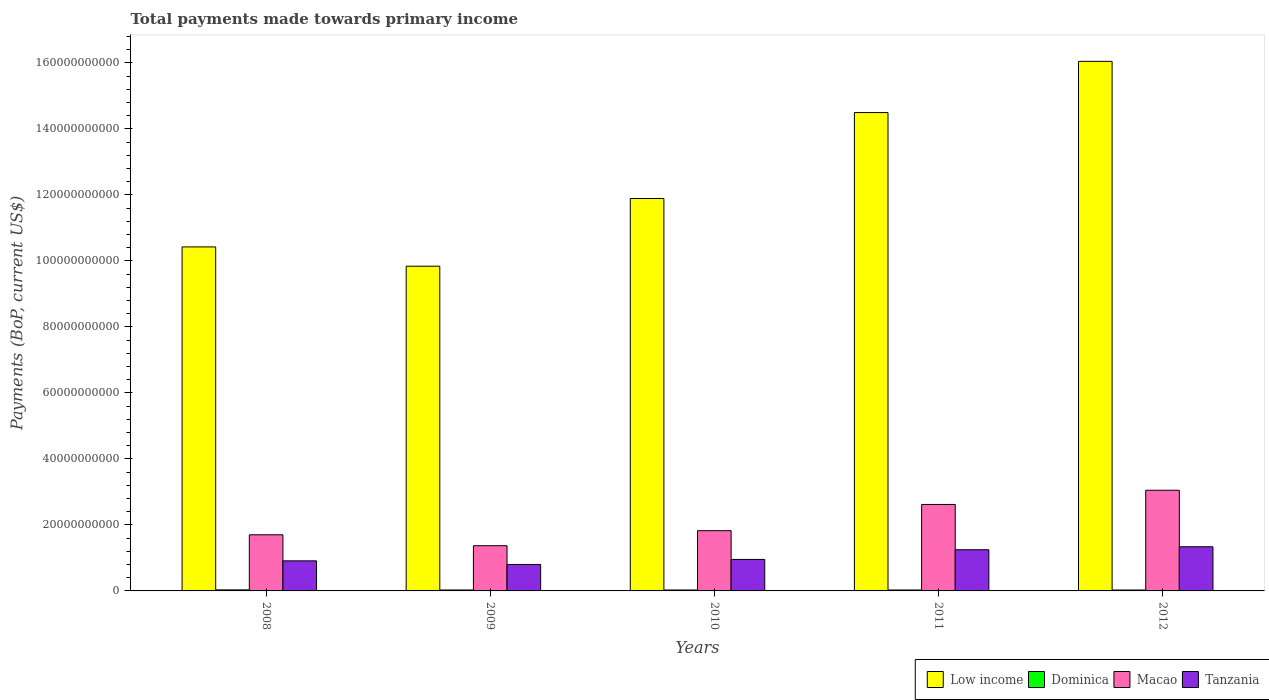How many different coloured bars are there?
Provide a short and direct response. 4. How many groups of bars are there?
Offer a terse response. 5. Are the number of bars on each tick of the X-axis equal?
Your answer should be very brief. Yes. How many bars are there on the 5th tick from the left?
Provide a succinct answer. 4. How many bars are there on the 4th tick from the right?
Your answer should be compact. 4. What is the label of the 2nd group of bars from the left?
Your answer should be very brief. 2009. What is the total payments made towards primary income in Tanzania in 2012?
Make the answer very short. 1.34e+1. Across all years, what is the maximum total payments made towards primary income in Dominica?
Give a very brief answer. 3.14e+08. Across all years, what is the minimum total payments made towards primary income in Macao?
Offer a very short reply. 1.37e+1. In which year was the total payments made towards primary income in Macao maximum?
Keep it short and to the point. 2012. What is the total total payments made towards primary income in Dominica in the graph?
Your response must be concise. 1.43e+09. What is the difference between the total payments made towards primary income in Macao in 2011 and that in 2012?
Give a very brief answer. -4.30e+09. What is the difference between the total payments made towards primary income in Low income in 2008 and the total payments made towards primary income in Macao in 2009?
Your response must be concise. 9.05e+1. What is the average total payments made towards primary income in Low income per year?
Your answer should be compact. 1.25e+11. In the year 2012, what is the difference between the total payments made towards primary income in Macao and total payments made towards primary income in Tanzania?
Make the answer very short. 1.71e+1. In how many years, is the total payments made towards primary income in Dominica greater than 160000000000 US$?
Offer a terse response. 0. What is the ratio of the total payments made towards primary income in Tanzania in 2010 to that in 2012?
Offer a very short reply. 0.71. Is the total payments made towards primary income in Macao in 2011 less than that in 2012?
Your response must be concise. Yes. What is the difference between the highest and the second highest total payments made towards primary income in Macao?
Offer a very short reply. 4.30e+09. What is the difference between the highest and the lowest total payments made towards primary income in Dominica?
Provide a short and direct response. 4.01e+07. What does the 3rd bar from the left in 2010 represents?
Your response must be concise. Macao. Is it the case that in every year, the sum of the total payments made towards primary income in Tanzania and total payments made towards primary income in Dominica is greater than the total payments made towards primary income in Macao?
Keep it short and to the point. No. Are all the bars in the graph horizontal?
Ensure brevity in your answer.  No. Are the values on the major ticks of Y-axis written in scientific E-notation?
Your response must be concise. No. Where does the legend appear in the graph?
Offer a terse response. Bottom right. How are the legend labels stacked?
Your answer should be compact. Horizontal. What is the title of the graph?
Your answer should be very brief. Total payments made towards primary income. What is the label or title of the X-axis?
Make the answer very short. Years. What is the label or title of the Y-axis?
Keep it short and to the point. Payments (BoP, current US$). What is the Payments (BoP, current US$) in Low income in 2008?
Offer a very short reply. 1.04e+11. What is the Payments (BoP, current US$) in Dominica in 2008?
Provide a succinct answer. 3.14e+08. What is the Payments (BoP, current US$) in Macao in 2008?
Provide a succinct answer. 1.70e+1. What is the Payments (BoP, current US$) of Tanzania in 2008?
Give a very brief answer. 9.11e+09. What is the Payments (BoP, current US$) of Low income in 2009?
Provide a succinct answer. 9.84e+1. What is the Payments (BoP, current US$) of Dominica in 2009?
Offer a very short reply. 2.85e+08. What is the Payments (BoP, current US$) of Macao in 2009?
Your answer should be compact. 1.37e+1. What is the Payments (BoP, current US$) in Tanzania in 2009?
Offer a very short reply. 8.02e+09. What is the Payments (BoP, current US$) of Low income in 2010?
Provide a succinct answer. 1.19e+11. What is the Payments (BoP, current US$) in Dominica in 2010?
Give a very brief answer. 2.80e+08. What is the Payments (BoP, current US$) in Macao in 2010?
Your answer should be compact. 1.83e+1. What is the Payments (BoP, current US$) in Tanzania in 2010?
Provide a succinct answer. 9.54e+09. What is the Payments (BoP, current US$) in Low income in 2011?
Your response must be concise. 1.45e+11. What is the Payments (BoP, current US$) in Dominica in 2011?
Give a very brief answer. 2.80e+08. What is the Payments (BoP, current US$) in Macao in 2011?
Your answer should be compact. 2.62e+1. What is the Payments (BoP, current US$) in Tanzania in 2011?
Your answer should be compact. 1.25e+1. What is the Payments (BoP, current US$) of Low income in 2012?
Provide a short and direct response. 1.60e+11. What is the Payments (BoP, current US$) in Dominica in 2012?
Provide a succinct answer. 2.74e+08. What is the Payments (BoP, current US$) in Macao in 2012?
Make the answer very short. 3.05e+1. What is the Payments (BoP, current US$) of Tanzania in 2012?
Offer a very short reply. 1.34e+1. Across all years, what is the maximum Payments (BoP, current US$) of Low income?
Offer a terse response. 1.60e+11. Across all years, what is the maximum Payments (BoP, current US$) of Dominica?
Your answer should be very brief. 3.14e+08. Across all years, what is the maximum Payments (BoP, current US$) in Macao?
Give a very brief answer. 3.05e+1. Across all years, what is the maximum Payments (BoP, current US$) of Tanzania?
Your response must be concise. 1.34e+1. Across all years, what is the minimum Payments (BoP, current US$) of Low income?
Give a very brief answer. 9.84e+1. Across all years, what is the minimum Payments (BoP, current US$) of Dominica?
Your answer should be very brief. 2.74e+08. Across all years, what is the minimum Payments (BoP, current US$) in Macao?
Give a very brief answer. 1.37e+1. Across all years, what is the minimum Payments (BoP, current US$) of Tanzania?
Keep it short and to the point. 8.02e+09. What is the total Payments (BoP, current US$) of Low income in the graph?
Provide a succinct answer. 6.27e+11. What is the total Payments (BoP, current US$) of Dominica in the graph?
Your answer should be compact. 1.43e+09. What is the total Payments (BoP, current US$) in Macao in the graph?
Offer a very short reply. 1.06e+11. What is the total Payments (BoP, current US$) in Tanzania in the graph?
Give a very brief answer. 5.25e+1. What is the difference between the Payments (BoP, current US$) of Low income in 2008 and that in 2009?
Your answer should be compact. 5.85e+09. What is the difference between the Payments (BoP, current US$) of Dominica in 2008 and that in 2009?
Your answer should be compact. 2.94e+07. What is the difference between the Payments (BoP, current US$) of Macao in 2008 and that in 2009?
Your response must be concise. 3.31e+09. What is the difference between the Payments (BoP, current US$) in Tanzania in 2008 and that in 2009?
Offer a very short reply. 1.10e+09. What is the difference between the Payments (BoP, current US$) of Low income in 2008 and that in 2010?
Ensure brevity in your answer.  -1.47e+1. What is the difference between the Payments (BoP, current US$) in Dominica in 2008 and that in 2010?
Give a very brief answer. 3.40e+07. What is the difference between the Payments (BoP, current US$) in Macao in 2008 and that in 2010?
Keep it short and to the point. -1.25e+09. What is the difference between the Payments (BoP, current US$) of Tanzania in 2008 and that in 2010?
Your answer should be very brief. -4.30e+08. What is the difference between the Payments (BoP, current US$) of Low income in 2008 and that in 2011?
Provide a short and direct response. -4.07e+1. What is the difference between the Payments (BoP, current US$) of Dominica in 2008 and that in 2011?
Provide a short and direct response. 3.38e+07. What is the difference between the Payments (BoP, current US$) of Macao in 2008 and that in 2011?
Make the answer very short. -9.19e+09. What is the difference between the Payments (BoP, current US$) of Tanzania in 2008 and that in 2011?
Your answer should be compact. -3.37e+09. What is the difference between the Payments (BoP, current US$) of Low income in 2008 and that in 2012?
Offer a terse response. -5.62e+1. What is the difference between the Payments (BoP, current US$) in Dominica in 2008 and that in 2012?
Offer a very short reply. 4.01e+07. What is the difference between the Payments (BoP, current US$) in Macao in 2008 and that in 2012?
Keep it short and to the point. -1.35e+1. What is the difference between the Payments (BoP, current US$) of Tanzania in 2008 and that in 2012?
Make the answer very short. -4.27e+09. What is the difference between the Payments (BoP, current US$) in Low income in 2009 and that in 2010?
Keep it short and to the point. -2.05e+1. What is the difference between the Payments (BoP, current US$) of Dominica in 2009 and that in 2010?
Offer a very short reply. 4.64e+06. What is the difference between the Payments (BoP, current US$) in Macao in 2009 and that in 2010?
Your answer should be compact. -4.56e+09. What is the difference between the Payments (BoP, current US$) of Tanzania in 2009 and that in 2010?
Offer a terse response. -1.53e+09. What is the difference between the Payments (BoP, current US$) of Low income in 2009 and that in 2011?
Your response must be concise. -4.66e+1. What is the difference between the Payments (BoP, current US$) of Dominica in 2009 and that in 2011?
Provide a succinct answer. 4.40e+06. What is the difference between the Payments (BoP, current US$) of Macao in 2009 and that in 2011?
Offer a terse response. -1.25e+1. What is the difference between the Payments (BoP, current US$) of Tanzania in 2009 and that in 2011?
Ensure brevity in your answer.  -4.46e+09. What is the difference between the Payments (BoP, current US$) in Low income in 2009 and that in 2012?
Offer a very short reply. -6.21e+1. What is the difference between the Payments (BoP, current US$) in Dominica in 2009 and that in 2012?
Your answer should be compact. 1.07e+07. What is the difference between the Payments (BoP, current US$) of Macao in 2009 and that in 2012?
Provide a succinct answer. -1.68e+1. What is the difference between the Payments (BoP, current US$) of Tanzania in 2009 and that in 2012?
Your answer should be very brief. -5.37e+09. What is the difference between the Payments (BoP, current US$) in Low income in 2010 and that in 2011?
Provide a short and direct response. -2.60e+1. What is the difference between the Payments (BoP, current US$) of Dominica in 2010 and that in 2011?
Keep it short and to the point. -2.36e+05. What is the difference between the Payments (BoP, current US$) in Macao in 2010 and that in 2011?
Give a very brief answer. -7.95e+09. What is the difference between the Payments (BoP, current US$) in Tanzania in 2010 and that in 2011?
Keep it short and to the point. -2.94e+09. What is the difference between the Payments (BoP, current US$) in Low income in 2010 and that in 2012?
Your response must be concise. -4.16e+1. What is the difference between the Payments (BoP, current US$) of Dominica in 2010 and that in 2012?
Make the answer very short. 6.09e+06. What is the difference between the Payments (BoP, current US$) in Macao in 2010 and that in 2012?
Make the answer very short. -1.22e+1. What is the difference between the Payments (BoP, current US$) in Tanzania in 2010 and that in 2012?
Provide a short and direct response. -3.84e+09. What is the difference between the Payments (BoP, current US$) in Low income in 2011 and that in 2012?
Your answer should be compact. -1.55e+1. What is the difference between the Payments (BoP, current US$) of Dominica in 2011 and that in 2012?
Your answer should be very brief. 6.32e+06. What is the difference between the Payments (BoP, current US$) of Macao in 2011 and that in 2012?
Make the answer very short. -4.30e+09. What is the difference between the Payments (BoP, current US$) of Tanzania in 2011 and that in 2012?
Offer a very short reply. -9.06e+08. What is the difference between the Payments (BoP, current US$) of Low income in 2008 and the Payments (BoP, current US$) of Dominica in 2009?
Ensure brevity in your answer.  1.04e+11. What is the difference between the Payments (BoP, current US$) of Low income in 2008 and the Payments (BoP, current US$) of Macao in 2009?
Provide a short and direct response. 9.05e+1. What is the difference between the Payments (BoP, current US$) of Low income in 2008 and the Payments (BoP, current US$) of Tanzania in 2009?
Ensure brevity in your answer.  9.62e+1. What is the difference between the Payments (BoP, current US$) of Dominica in 2008 and the Payments (BoP, current US$) of Macao in 2009?
Your answer should be compact. -1.34e+1. What is the difference between the Payments (BoP, current US$) of Dominica in 2008 and the Payments (BoP, current US$) of Tanzania in 2009?
Make the answer very short. -7.70e+09. What is the difference between the Payments (BoP, current US$) in Macao in 2008 and the Payments (BoP, current US$) in Tanzania in 2009?
Make the answer very short. 8.99e+09. What is the difference between the Payments (BoP, current US$) of Low income in 2008 and the Payments (BoP, current US$) of Dominica in 2010?
Your answer should be compact. 1.04e+11. What is the difference between the Payments (BoP, current US$) of Low income in 2008 and the Payments (BoP, current US$) of Macao in 2010?
Give a very brief answer. 8.60e+1. What is the difference between the Payments (BoP, current US$) of Low income in 2008 and the Payments (BoP, current US$) of Tanzania in 2010?
Keep it short and to the point. 9.47e+1. What is the difference between the Payments (BoP, current US$) of Dominica in 2008 and the Payments (BoP, current US$) of Macao in 2010?
Offer a very short reply. -1.79e+1. What is the difference between the Payments (BoP, current US$) in Dominica in 2008 and the Payments (BoP, current US$) in Tanzania in 2010?
Provide a short and direct response. -9.23e+09. What is the difference between the Payments (BoP, current US$) in Macao in 2008 and the Payments (BoP, current US$) in Tanzania in 2010?
Offer a very short reply. 7.47e+09. What is the difference between the Payments (BoP, current US$) of Low income in 2008 and the Payments (BoP, current US$) of Dominica in 2011?
Provide a short and direct response. 1.04e+11. What is the difference between the Payments (BoP, current US$) in Low income in 2008 and the Payments (BoP, current US$) in Macao in 2011?
Provide a succinct answer. 7.80e+1. What is the difference between the Payments (BoP, current US$) in Low income in 2008 and the Payments (BoP, current US$) in Tanzania in 2011?
Your answer should be very brief. 9.18e+1. What is the difference between the Payments (BoP, current US$) of Dominica in 2008 and the Payments (BoP, current US$) of Macao in 2011?
Make the answer very short. -2.59e+1. What is the difference between the Payments (BoP, current US$) in Dominica in 2008 and the Payments (BoP, current US$) in Tanzania in 2011?
Your answer should be compact. -1.22e+1. What is the difference between the Payments (BoP, current US$) of Macao in 2008 and the Payments (BoP, current US$) of Tanzania in 2011?
Offer a very short reply. 4.53e+09. What is the difference between the Payments (BoP, current US$) of Low income in 2008 and the Payments (BoP, current US$) of Dominica in 2012?
Give a very brief answer. 1.04e+11. What is the difference between the Payments (BoP, current US$) of Low income in 2008 and the Payments (BoP, current US$) of Macao in 2012?
Offer a very short reply. 7.37e+1. What is the difference between the Payments (BoP, current US$) of Low income in 2008 and the Payments (BoP, current US$) of Tanzania in 2012?
Give a very brief answer. 9.08e+1. What is the difference between the Payments (BoP, current US$) in Dominica in 2008 and the Payments (BoP, current US$) in Macao in 2012?
Ensure brevity in your answer.  -3.02e+1. What is the difference between the Payments (BoP, current US$) in Dominica in 2008 and the Payments (BoP, current US$) in Tanzania in 2012?
Offer a terse response. -1.31e+1. What is the difference between the Payments (BoP, current US$) in Macao in 2008 and the Payments (BoP, current US$) in Tanzania in 2012?
Provide a succinct answer. 3.62e+09. What is the difference between the Payments (BoP, current US$) of Low income in 2009 and the Payments (BoP, current US$) of Dominica in 2010?
Ensure brevity in your answer.  9.81e+1. What is the difference between the Payments (BoP, current US$) of Low income in 2009 and the Payments (BoP, current US$) of Macao in 2010?
Keep it short and to the point. 8.01e+1. What is the difference between the Payments (BoP, current US$) in Low income in 2009 and the Payments (BoP, current US$) in Tanzania in 2010?
Your response must be concise. 8.88e+1. What is the difference between the Payments (BoP, current US$) in Dominica in 2009 and the Payments (BoP, current US$) in Macao in 2010?
Give a very brief answer. -1.80e+1. What is the difference between the Payments (BoP, current US$) in Dominica in 2009 and the Payments (BoP, current US$) in Tanzania in 2010?
Provide a succinct answer. -9.26e+09. What is the difference between the Payments (BoP, current US$) in Macao in 2009 and the Payments (BoP, current US$) in Tanzania in 2010?
Your answer should be very brief. 4.16e+09. What is the difference between the Payments (BoP, current US$) of Low income in 2009 and the Payments (BoP, current US$) of Dominica in 2011?
Provide a succinct answer. 9.81e+1. What is the difference between the Payments (BoP, current US$) in Low income in 2009 and the Payments (BoP, current US$) in Macao in 2011?
Ensure brevity in your answer.  7.22e+1. What is the difference between the Payments (BoP, current US$) of Low income in 2009 and the Payments (BoP, current US$) of Tanzania in 2011?
Provide a succinct answer. 8.59e+1. What is the difference between the Payments (BoP, current US$) in Dominica in 2009 and the Payments (BoP, current US$) in Macao in 2011?
Provide a succinct answer. -2.59e+1. What is the difference between the Payments (BoP, current US$) in Dominica in 2009 and the Payments (BoP, current US$) in Tanzania in 2011?
Make the answer very short. -1.22e+1. What is the difference between the Payments (BoP, current US$) of Macao in 2009 and the Payments (BoP, current US$) of Tanzania in 2011?
Your response must be concise. 1.22e+09. What is the difference between the Payments (BoP, current US$) in Low income in 2009 and the Payments (BoP, current US$) in Dominica in 2012?
Offer a terse response. 9.81e+1. What is the difference between the Payments (BoP, current US$) in Low income in 2009 and the Payments (BoP, current US$) in Macao in 2012?
Provide a short and direct response. 6.79e+1. What is the difference between the Payments (BoP, current US$) of Low income in 2009 and the Payments (BoP, current US$) of Tanzania in 2012?
Offer a very short reply. 8.50e+1. What is the difference between the Payments (BoP, current US$) of Dominica in 2009 and the Payments (BoP, current US$) of Macao in 2012?
Make the answer very short. -3.02e+1. What is the difference between the Payments (BoP, current US$) of Dominica in 2009 and the Payments (BoP, current US$) of Tanzania in 2012?
Give a very brief answer. -1.31e+1. What is the difference between the Payments (BoP, current US$) in Macao in 2009 and the Payments (BoP, current US$) in Tanzania in 2012?
Your response must be concise. 3.15e+08. What is the difference between the Payments (BoP, current US$) of Low income in 2010 and the Payments (BoP, current US$) of Dominica in 2011?
Give a very brief answer. 1.19e+11. What is the difference between the Payments (BoP, current US$) in Low income in 2010 and the Payments (BoP, current US$) in Macao in 2011?
Give a very brief answer. 9.27e+1. What is the difference between the Payments (BoP, current US$) in Low income in 2010 and the Payments (BoP, current US$) in Tanzania in 2011?
Give a very brief answer. 1.06e+11. What is the difference between the Payments (BoP, current US$) of Dominica in 2010 and the Payments (BoP, current US$) of Macao in 2011?
Your response must be concise. -2.59e+1. What is the difference between the Payments (BoP, current US$) of Dominica in 2010 and the Payments (BoP, current US$) of Tanzania in 2011?
Your response must be concise. -1.22e+1. What is the difference between the Payments (BoP, current US$) of Macao in 2010 and the Payments (BoP, current US$) of Tanzania in 2011?
Offer a terse response. 5.78e+09. What is the difference between the Payments (BoP, current US$) of Low income in 2010 and the Payments (BoP, current US$) of Dominica in 2012?
Provide a succinct answer. 1.19e+11. What is the difference between the Payments (BoP, current US$) of Low income in 2010 and the Payments (BoP, current US$) of Macao in 2012?
Give a very brief answer. 8.84e+1. What is the difference between the Payments (BoP, current US$) of Low income in 2010 and the Payments (BoP, current US$) of Tanzania in 2012?
Provide a short and direct response. 1.06e+11. What is the difference between the Payments (BoP, current US$) in Dominica in 2010 and the Payments (BoP, current US$) in Macao in 2012?
Give a very brief answer. -3.02e+1. What is the difference between the Payments (BoP, current US$) in Dominica in 2010 and the Payments (BoP, current US$) in Tanzania in 2012?
Provide a succinct answer. -1.31e+1. What is the difference between the Payments (BoP, current US$) in Macao in 2010 and the Payments (BoP, current US$) in Tanzania in 2012?
Make the answer very short. 4.87e+09. What is the difference between the Payments (BoP, current US$) in Low income in 2011 and the Payments (BoP, current US$) in Dominica in 2012?
Keep it short and to the point. 1.45e+11. What is the difference between the Payments (BoP, current US$) in Low income in 2011 and the Payments (BoP, current US$) in Macao in 2012?
Make the answer very short. 1.14e+11. What is the difference between the Payments (BoP, current US$) of Low income in 2011 and the Payments (BoP, current US$) of Tanzania in 2012?
Your answer should be compact. 1.32e+11. What is the difference between the Payments (BoP, current US$) in Dominica in 2011 and the Payments (BoP, current US$) in Macao in 2012?
Ensure brevity in your answer.  -3.02e+1. What is the difference between the Payments (BoP, current US$) in Dominica in 2011 and the Payments (BoP, current US$) in Tanzania in 2012?
Give a very brief answer. -1.31e+1. What is the difference between the Payments (BoP, current US$) of Macao in 2011 and the Payments (BoP, current US$) of Tanzania in 2012?
Your answer should be compact. 1.28e+1. What is the average Payments (BoP, current US$) of Low income per year?
Your answer should be very brief. 1.25e+11. What is the average Payments (BoP, current US$) in Dominica per year?
Your response must be concise. 2.87e+08. What is the average Payments (BoP, current US$) in Macao per year?
Give a very brief answer. 2.11e+1. What is the average Payments (BoP, current US$) in Tanzania per year?
Keep it short and to the point. 1.05e+1. In the year 2008, what is the difference between the Payments (BoP, current US$) in Low income and Payments (BoP, current US$) in Dominica?
Give a very brief answer. 1.04e+11. In the year 2008, what is the difference between the Payments (BoP, current US$) of Low income and Payments (BoP, current US$) of Macao?
Your answer should be compact. 8.72e+1. In the year 2008, what is the difference between the Payments (BoP, current US$) of Low income and Payments (BoP, current US$) of Tanzania?
Your answer should be compact. 9.51e+1. In the year 2008, what is the difference between the Payments (BoP, current US$) in Dominica and Payments (BoP, current US$) in Macao?
Provide a succinct answer. -1.67e+1. In the year 2008, what is the difference between the Payments (BoP, current US$) in Dominica and Payments (BoP, current US$) in Tanzania?
Provide a short and direct response. -8.80e+09. In the year 2008, what is the difference between the Payments (BoP, current US$) in Macao and Payments (BoP, current US$) in Tanzania?
Provide a short and direct response. 7.90e+09. In the year 2009, what is the difference between the Payments (BoP, current US$) of Low income and Payments (BoP, current US$) of Dominica?
Give a very brief answer. 9.81e+1. In the year 2009, what is the difference between the Payments (BoP, current US$) of Low income and Payments (BoP, current US$) of Macao?
Ensure brevity in your answer.  8.47e+1. In the year 2009, what is the difference between the Payments (BoP, current US$) in Low income and Payments (BoP, current US$) in Tanzania?
Provide a succinct answer. 9.04e+1. In the year 2009, what is the difference between the Payments (BoP, current US$) in Dominica and Payments (BoP, current US$) in Macao?
Ensure brevity in your answer.  -1.34e+1. In the year 2009, what is the difference between the Payments (BoP, current US$) in Dominica and Payments (BoP, current US$) in Tanzania?
Your answer should be very brief. -7.73e+09. In the year 2009, what is the difference between the Payments (BoP, current US$) in Macao and Payments (BoP, current US$) in Tanzania?
Provide a short and direct response. 5.68e+09. In the year 2010, what is the difference between the Payments (BoP, current US$) of Low income and Payments (BoP, current US$) of Dominica?
Provide a short and direct response. 1.19e+11. In the year 2010, what is the difference between the Payments (BoP, current US$) in Low income and Payments (BoP, current US$) in Macao?
Your answer should be compact. 1.01e+11. In the year 2010, what is the difference between the Payments (BoP, current US$) of Low income and Payments (BoP, current US$) of Tanzania?
Offer a very short reply. 1.09e+11. In the year 2010, what is the difference between the Payments (BoP, current US$) of Dominica and Payments (BoP, current US$) of Macao?
Ensure brevity in your answer.  -1.80e+1. In the year 2010, what is the difference between the Payments (BoP, current US$) of Dominica and Payments (BoP, current US$) of Tanzania?
Provide a short and direct response. -9.26e+09. In the year 2010, what is the difference between the Payments (BoP, current US$) in Macao and Payments (BoP, current US$) in Tanzania?
Offer a terse response. 8.71e+09. In the year 2011, what is the difference between the Payments (BoP, current US$) in Low income and Payments (BoP, current US$) in Dominica?
Keep it short and to the point. 1.45e+11. In the year 2011, what is the difference between the Payments (BoP, current US$) in Low income and Payments (BoP, current US$) in Macao?
Keep it short and to the point. 1.19e+11. In the year 2011, what is the difference between the Payments (BoP, current US$) in Low income and Payments (BoP, current US$) in Tanzania?
Your response must be concise. 1.32e+11. In the year 2011, what is the difference between the Payments (BoP, current US$) of Dominica and Payments (BoP, current US$) of Macao?
Give a very brief answer. -2.59e+1. In the year 2011, what is the difference between the Payments (BoP, current US$) of Dominica and Payments (BoP, current US$) of Tanzania?
Provide a short and direct response. -1.22e+1. In the year 2011, what is the difference between the Payments (BoP, current US$) in Macao and Payments (BoP, current US$) in Tanzania?
Offer a terse response. 1.37e+1. In the year 2012, what is the difference between the Payments (BoP, current US$) of Low income and Payments (BoP, current US$) of Dominica?
Make the answer very short. 1.60e+11. In the year 2012, what is the difference between the Payments (BoP, current US$) in Low income and Payments (BoP, current US$) in Macao?
Ensure brevity in your answer.  1.30e+11. In the year 2012, what is the difference between the Payments (BoP, current US$) in Low income and Payments (BoP, current US$) in Tanzania?
Your answer should be very brief. 1.47e+11. In the year 2012, what is the difference between the Payments (BoP, current US$) in Dominica and Payments (BoP, current US$) in Macao?
Give a very brief answer. -3.02e+1. In the year 2012, what is the difference between the Payments (BoP, current US$) in Dominica and Payments (BoP, current US$) in Tanzania?
Provide a succinct answer. -1.31e+1. In the year 2012, what is the difference between the Payments (BoP, current US$) in Macao and Payments (BoP, current US$) in Tanzania?
Offer a terse response. 1.71e+1. What is the ratio of the Payments (BoP, current US$) of Low income in 2008 to that in 2009?
Provide a short and direct response. 1.06. What is the ratio of the Payments (BoP, current US$) in Dominica in 2008 to that in 2009?
Offer a very short reply. 1.1. What is the ratio of the Payments (BoP, current US$) in Macao in 2008 to that in 2009?
Your answer should be compact. 1.24. What is the ratio of the Payments (BoP, current US$) in Tanzania in 2008 to that in 2009?
Make the answer very short. 1.14. What is the ratio of the Payments (BoP, current US$) in Low income in 2008 to that in 2010?
Provide a succinct answer. 0.88. What is the ratio of the Payments (BoP, current US$) of Dominica in 2008 to that in 2010?
Keep it short and to the point. 1.12. What is the ratio of the Payments (BoP, current US$) in Macao in 2008 to that in 2010?
Your answer should be compact. 0.93. What is the ratio of the Payments (BoP, current US$) in Tanzania in 2008 to that in 2010?
Provide a short and direct response. 0.95. What is the ratio of the Payments (BoP, current US$) of Low income in 2008 to that in 2011?
Offer a very short reply. 0.72. What is the ratio of the Payments (BoP, current US$) of Dominica in 2008 to that in 2011?
Your answer should be very brief. 1.12. What is the ratio of the Payments (BoP, current US$) of Macao in 2008 to that in 2011?
Ensure brevity in your answer.  0.65. What is the ratio of the Payments (BoP, current US$) in Tanzania in 2008 to that in 2011?
Ensure brevity in your answer.  0.73. What is the ratio of the Payments (BoP, current US$) of Low income in 2008 to that in 2012?
Your answer should be compact. 0.65. What is the ratio of the Payments (BoP, current US$) in Dominica in 2008 to that in 2012?
Your answer should be very brief. 1.15. What is the ratio of the Payments (BoP, current US$) in Macao in 2008 to that in 2012?
Provide a short and direct response. 0.56. What is the ratio of the Payments (BoP, current US$) of Tanzania in 2008 to that in 2012?
Ensure brevity in your answer.  0.68. What is the ratio of the Payments (BoP, current US$) in Low income in 2009 to that in 2010?
Keep it short and to the point. 0.83. What is the ratio of the Payments (BoP, current US$) in Dominica in 2009 to that in 2010?
Your answer should be very brief. 1.02. What is the ratio of the Payments (BoP, current US$) in Macao in 2009 to that in 2010?
Offer a terse response. 0.75. What is the ratio of the Payments (BoP, current US$) in Tanzania in 2009 to that in 2010?
Provide a succinct answer. 0.84. What is the ratio of the Payments (BoP, current US$) of Low income in 2009 to that in 2011?
Your response must be concise. 0.68. What is the ratio of the Payments (BoP, current US$) of Dominica in 2009 to that in 2011?
Provide a succinct answer. 1.02. What is the ratio of the Payments (BoP, current US$) of Macao in 2009 to that in 2011?
Ensure brevity in your answer.  0.52. What is the ratio of the Payments (BoP, current US$) of Tanzania in 2009 to that in 2011?
Keep it short and to the point. 0.64. What is the ratio of the Payments (BoP, current US$) of Low income in 2009 to that in 2012?
Make the answer very short. 0.61. What is the ratio of the Payments (BoP, current US$) of Dominica in 2009 to that in 2012?
Your answer should be compact. 1.04. What is the ratio of the Payments (BoP, current US$) of Macao in 2009 to that in 2012?
Your response must be concise. 0.45. What is the ratio of the Payments (BoP, current US$) of Tanzania in 2009 to that in 2012?
Give a very brief answer. 0.6. What is the ratio of the Payments (BoP, current US$) of Low income in 2010 to that in 2011?
Your response must be concise. 0.82. What is the ratio of the Payments (BoP, current US$) of Dominica in 2010 to that in 2011?
Provide a succinct answer. 1. What is the ratio of the Payments (BoP, current US$) in Macao in 2010 to that in 2011?
Provide a succinct answer. 0.7. What is the ratio of the Payments (BoP, current US$) of Tanzania in 2010 to that in 2011?
Provide a short and direct response. 0.76. What is the ratio of the Payments (BoP, current US$) of Low income in 2010 to that in 2012?
Your answer should be very brief. 0.74. What is the ratio of the Payments (BoP, current US$) of Dominica in 2010 to that in 2012?
Ensure brevity in your answer.  1.02. What is the ratio of the Payments (BoP, current US$) in Macao in 2010 to that in 2012?
Your response must be concise. 0.6. What is the ratio of the Payments (BoP, current US$) in Tanzania in 2010 to that in 2012?
Your response must be concise. 0.71. What is the ratio of the Payments (BoP, current US$) in Low income in 2011 to that in 2012?
Your answer should be compact. 0.9. What is the ratio of the Payments (BoP, current US$) of Dominica in 2011 to that in 2012?
Your response must be concise. 1.02. What is the ratio of the Payments (BoP, current US$) in Macao in 2011 to that in 2012?
Your answer should be very brief. 0.86. What is the ratio of the Payments (BoP, current US$) in Tanzania in 2011 to that in 2012?
Offer a terse response. 0.93. What is the difference between the highest and the second highest Payments (BoP, current US$) in Low income?
Offer a very short reply. 1.55e+1. What is the difference between the highest and the second highest Payments (BoP, current US$) of Dominica?
Provide a short and direct response. 2.94e+07. What is the difference between the highest and the second highest Payments (BoP, current US$) of Macao?
Your answer should be compact. 4.30e+09. What is the difference between the highest and the second highest Payments (BoP, current US$) in Tanzania?
Offer a terse response. 9.06e+08. What is the difference between the highest and the lowest Payments (BoP, current US$) of Low income?
Provide a succinct answer. 6.21e+1. What is the difference between the highest and the lowest Payments (BoP, current US$) in Dominica?
Give a very brief answer. 4.01e+07. What is the difference between the highest and the lowest Payments (BoP, current US$) of Macao?
Make the answer very short. 1.68e+1. What is the difference between the highest and the lowest Payments (BoP, current US$) in Tanzania?
Your answer should be very brief. 5.37e+09. 